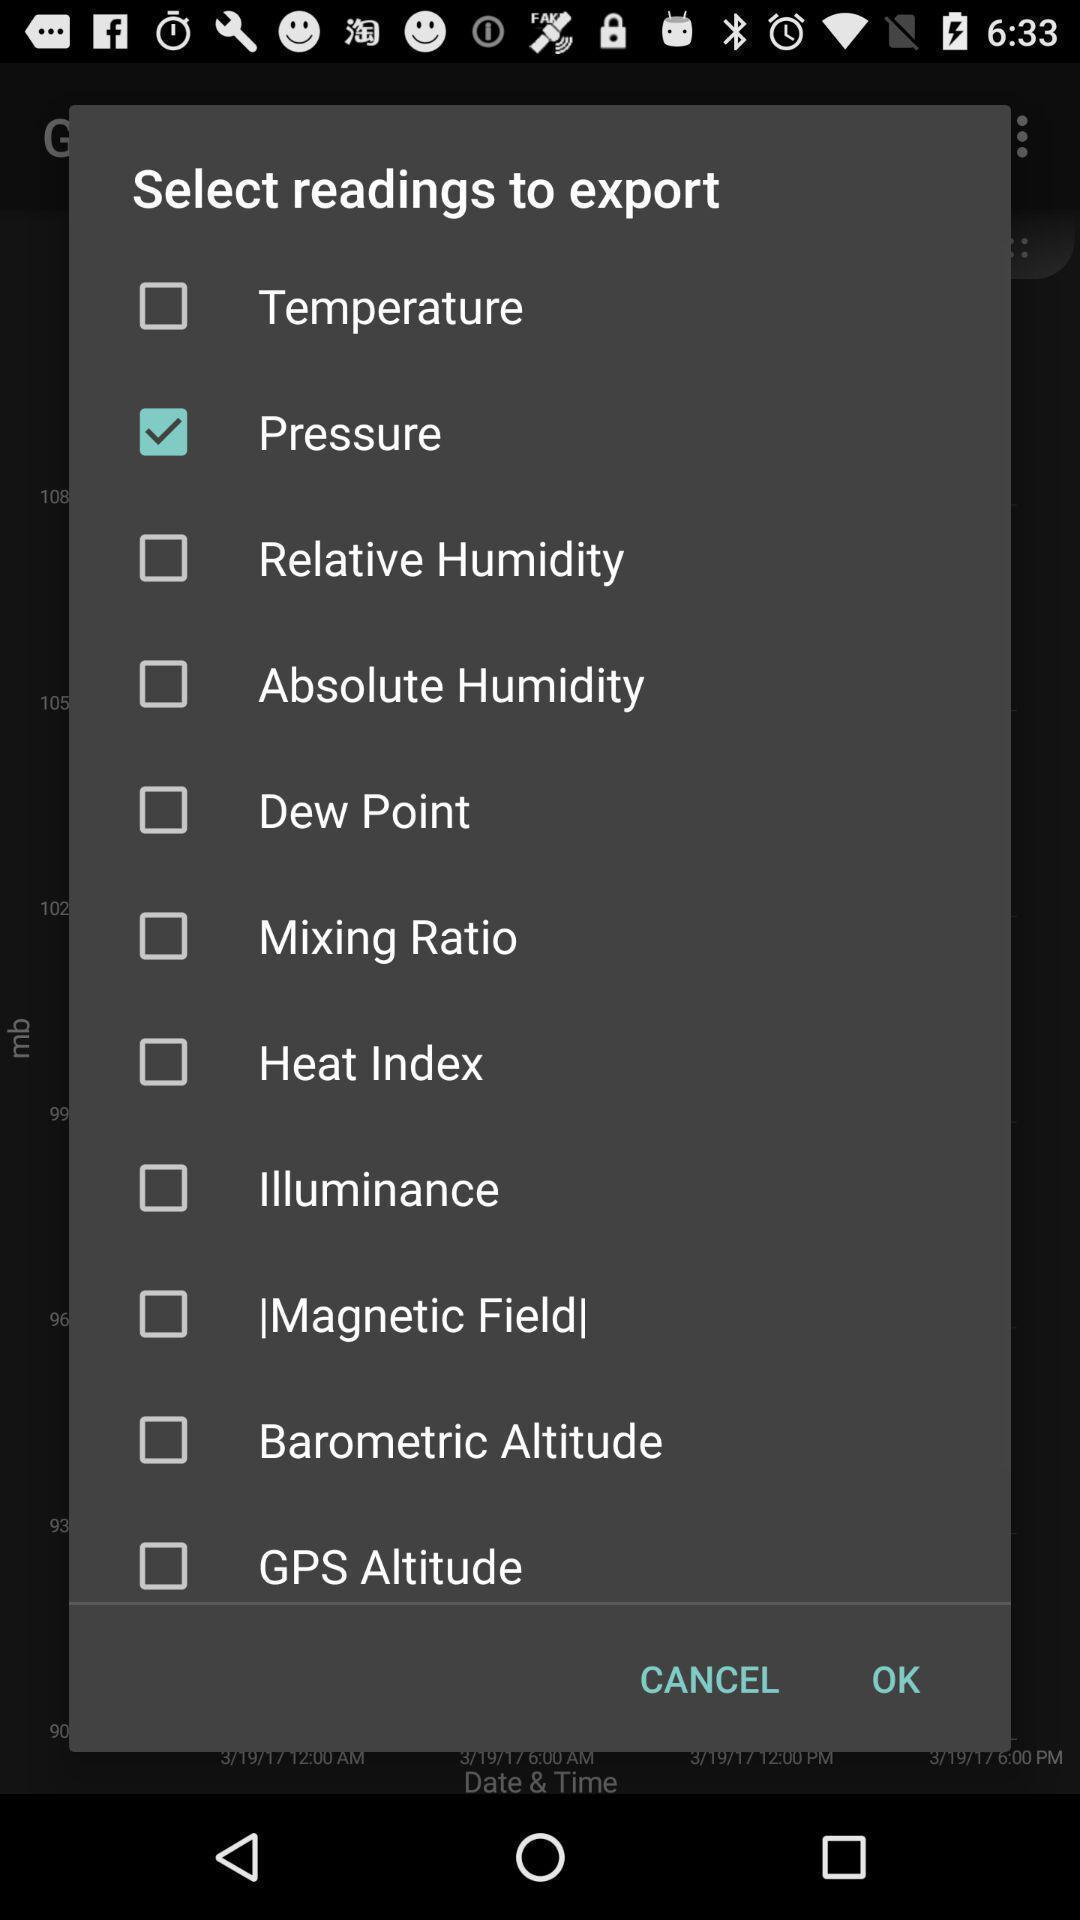Please provide a description for this image. Pop up showing the different types of readings to select. 